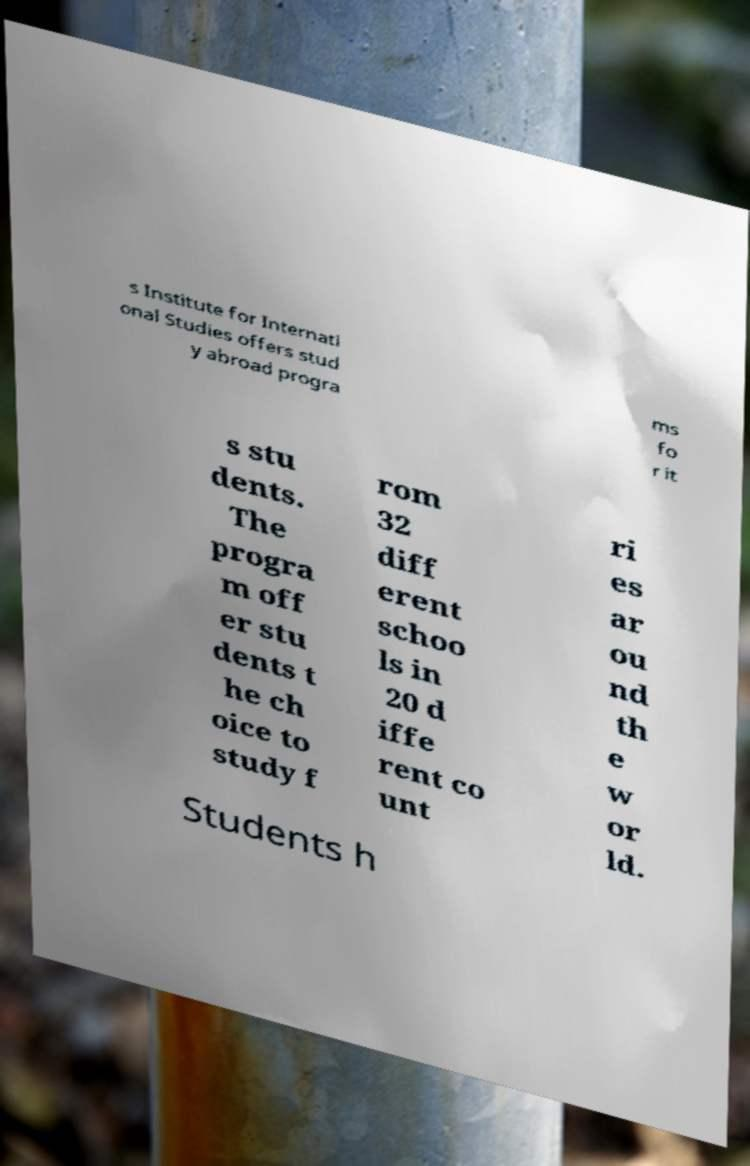Can you accurately transcribe the text from the provided image for me? s Institute for Internati onal Studies offers stud y abroad progra ms fo r it s stu dents. The progra m off er stu dents t he ch oice to study f rom 32 diff erent schoo ls in 20 d iffe rent co unt ri es ar ou nd th e w or ld. Students h 